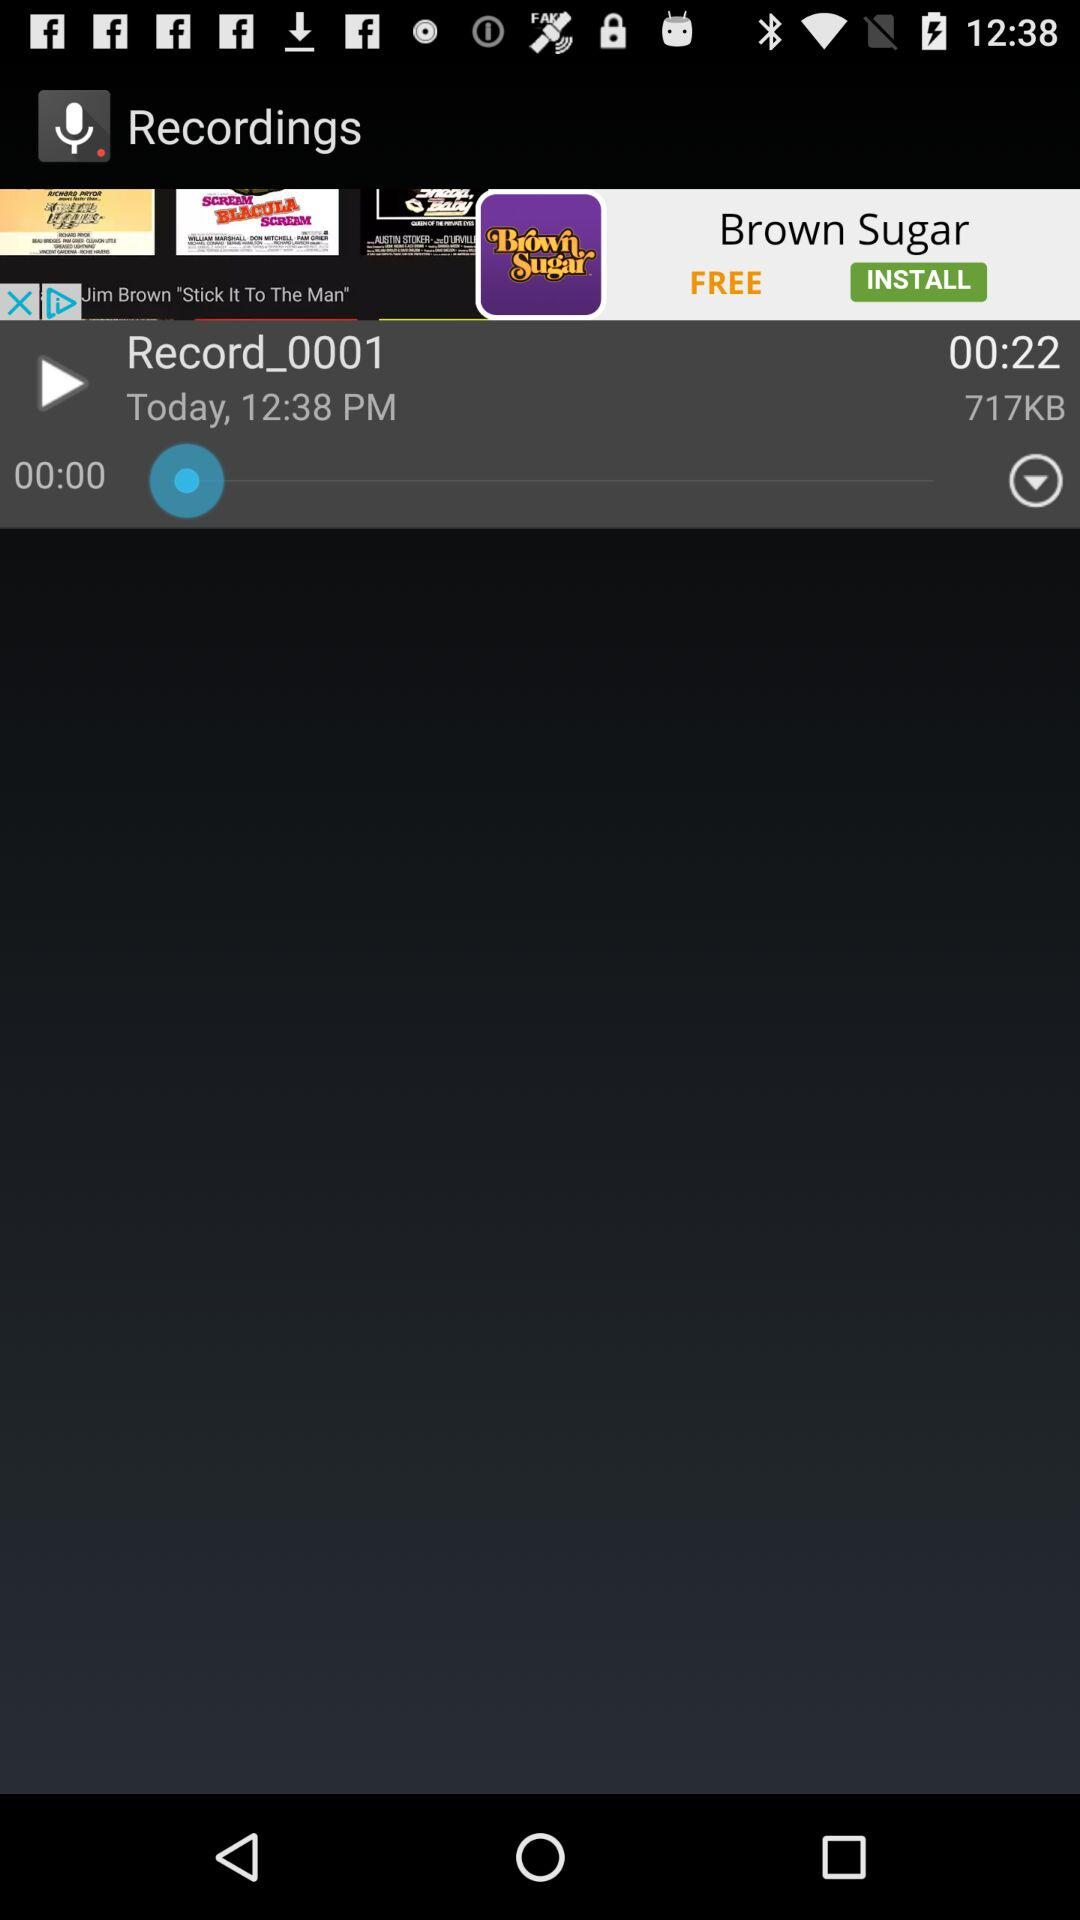What is the size of the recording in KB? The size of the recording is 717 KB. 